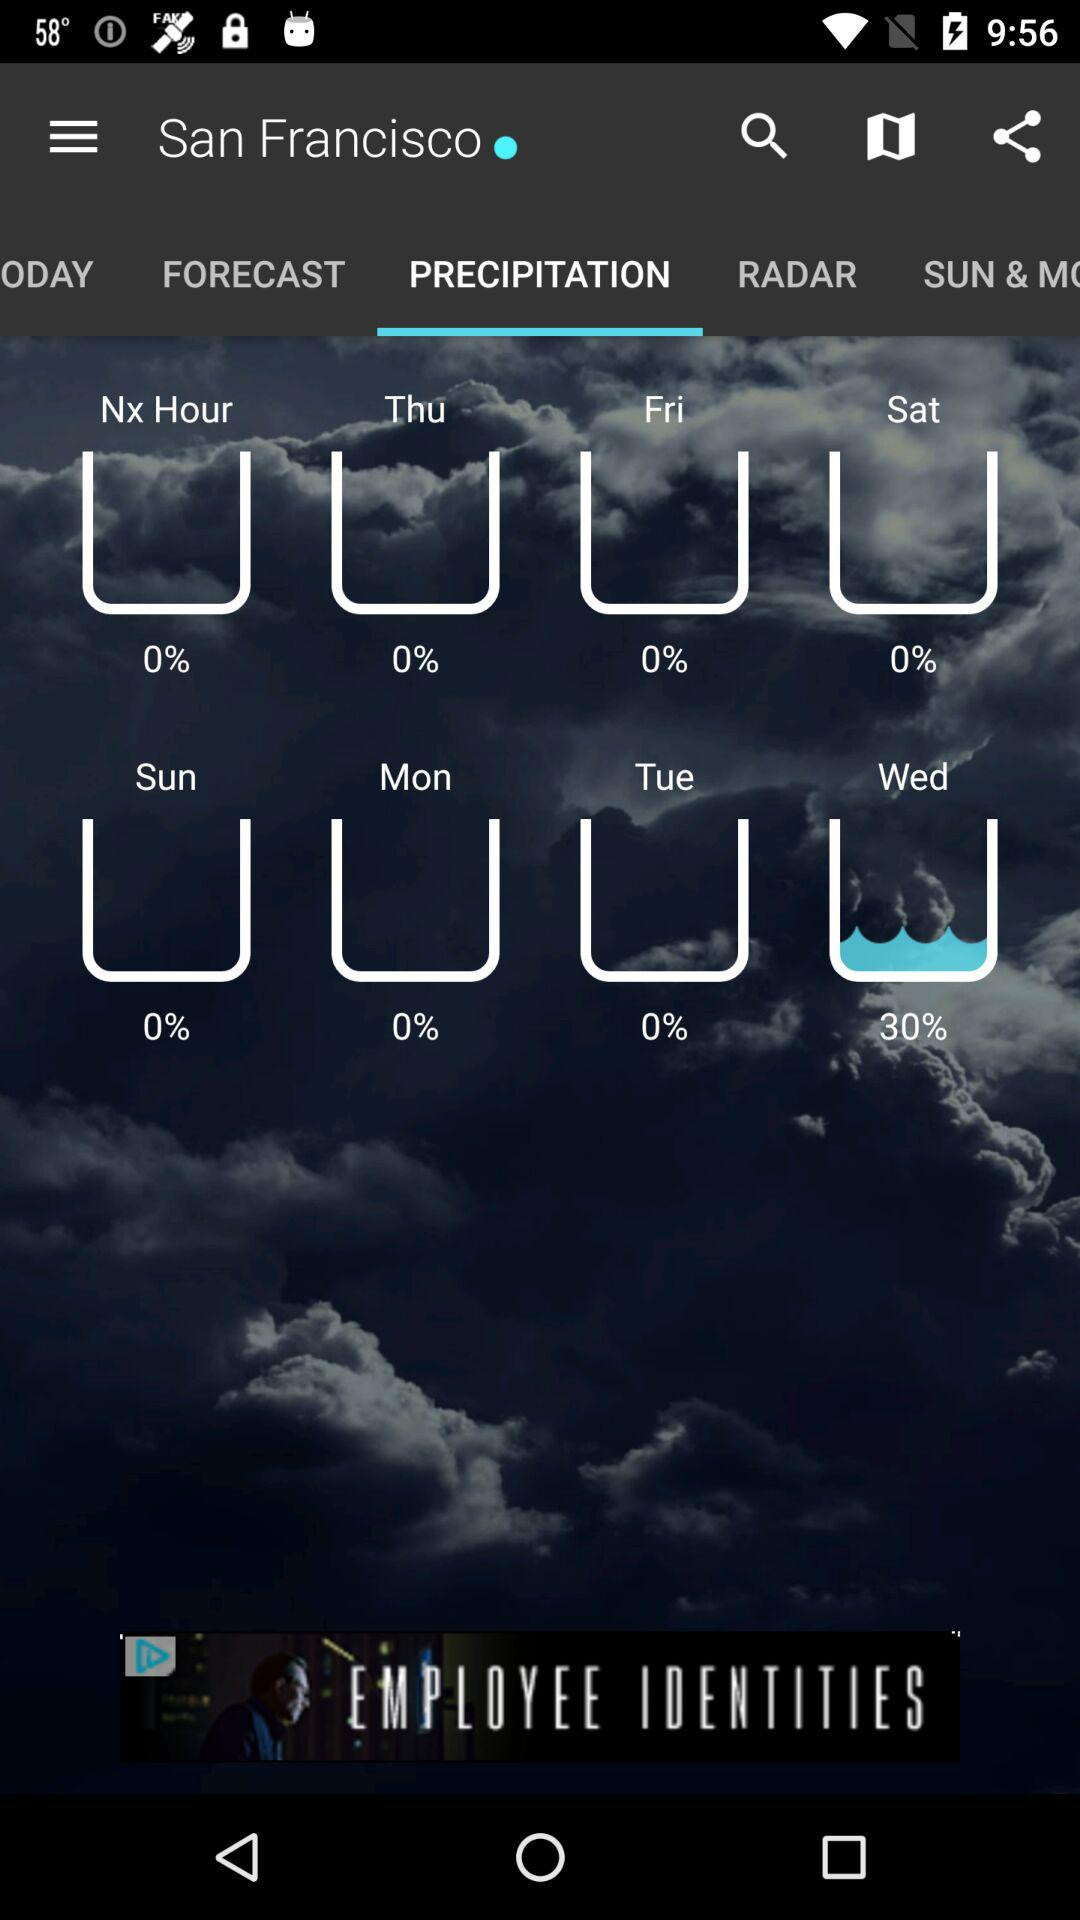What is the precipitation percentage for Thursday?
Answer the question using a single word or phrase. 0% 